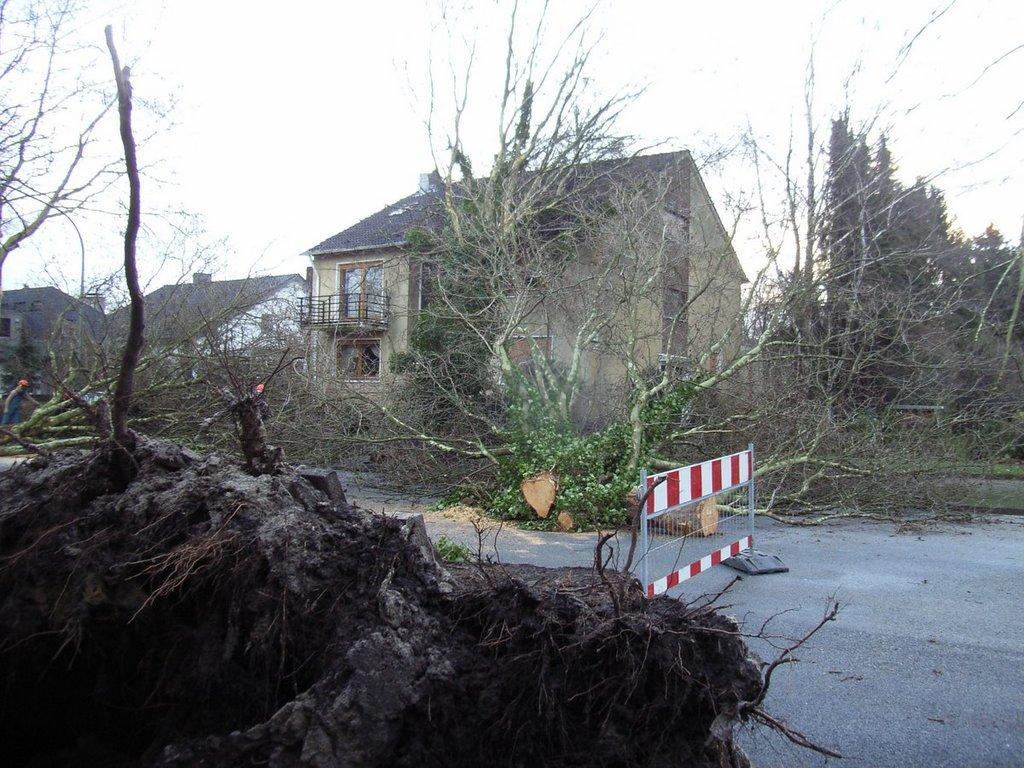What is the primary feature of the landscape in the image? There are many trees in the image. What is located at the bottom of the image? There is a road at the bottom of the image. What structure can be seen in the middle of the image? There is a gate in the middle of the image. How many houses are visible in the background of the image? There are three houses in the background of the image. What is visible at the top of the image? The sky is visible at the top of the image. What type of sign can be seen hanging from the gate in the image? There is no sign hanging from the gate in the image; only the gate itself is visible. Are there any grapes growing on the trees in the image? There is no indication of grapes or any other fruit growing on the trees in the image. 